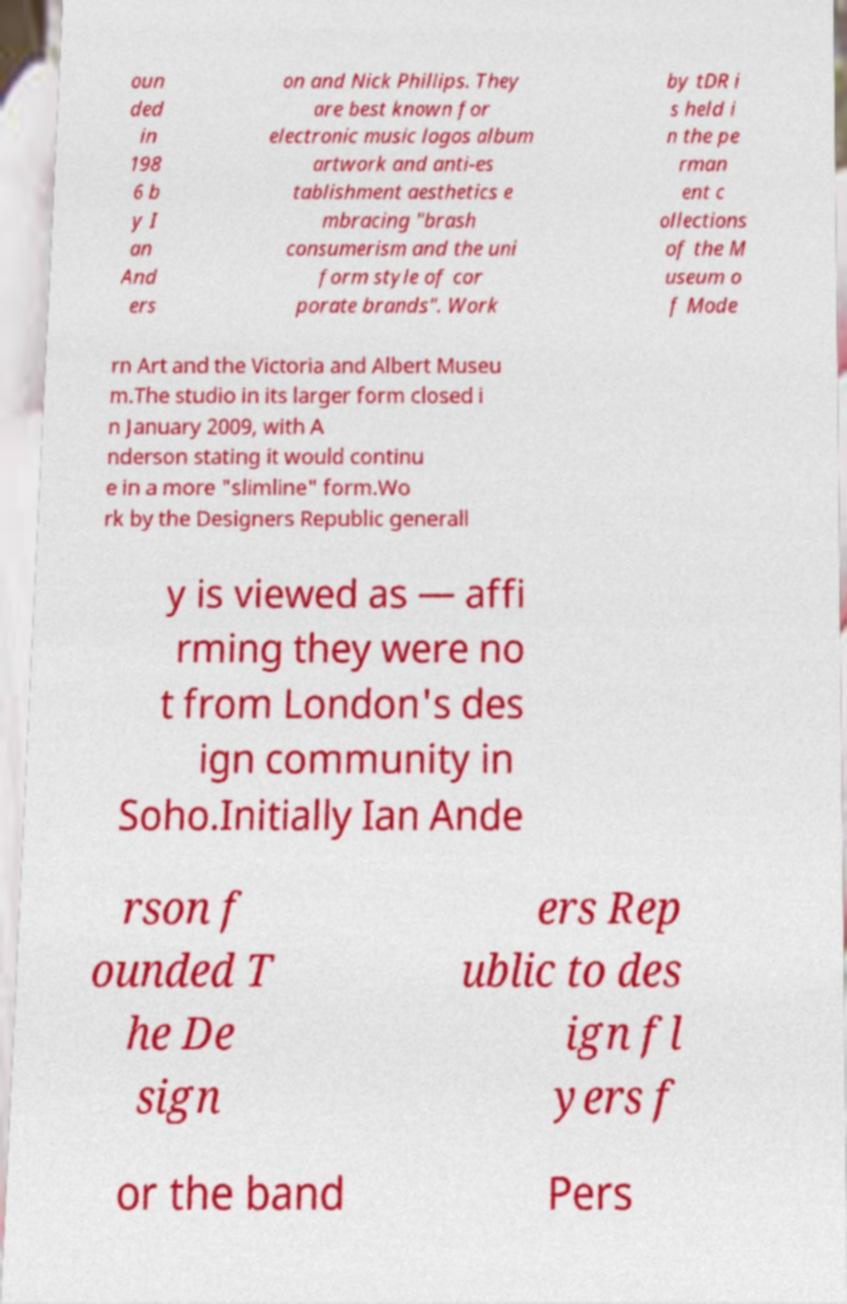Please identify and transcribe the text found in this image. oun ded in 198 6 b y I an And ers on and Nick Phillips. They are best known for electronic music logos album artwork and anti-es tablishment aesthetics e mbracing "brash consumerism and the uni form style of cor porate brands". Work by tDR i s held i n the pe rman ent c ollections of the M useum o f Mode rn Art and the Victoria and Albert Museu m.The studio in its larger form closed i n January 2009, with A nderson stating it would continu e in a more "slimline" form.Wo rk by the Designers Republic generall y is viewed as — affi rming they were no t from London's des ign community in Soho.Initially Ian Ande rson f ounded T he De sign ers Rep ublic to des ign fl yers f or the band Pers 